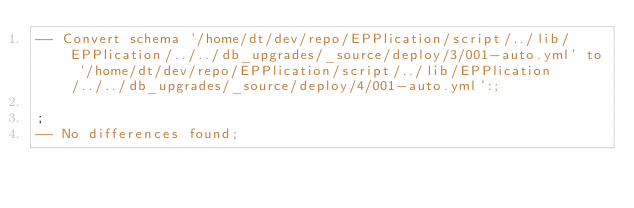<code> <loc_0><loc_0><loc_500><loc_500><_SQL_>-- Convert schema '/home/dt/dev/repo/EPPlication/script/../lib/EPPlication/../../db_upgrades/_source/deploy/3/001-auto.yml' to '/home/dt/dev/repo/EPPlication/script/../lib/EPPlication/../../db_upgrades/_source/deploy/4/001-auto.yml':;

;
-- No differences found;

</code> 